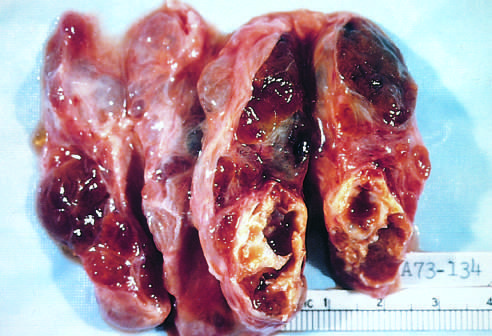does the coarsely nodular gland contain areas of fibrosis and cystic change?
Answer the question using a single word or phrase. Yes 